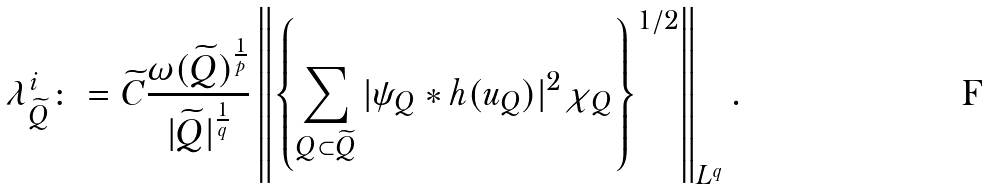Convert formula to latex. <formula><loc_0><loc_0><loc_500><loc_500>\lambda _ { \widetilde { Q } } ^ { i } \colon = \widetilde { C } \frac { \omega ( \widetilde { Q } ) ^ { \frac { 1 } { p } } } { | \widetilde { Q } | ^ { \frac { 1 } { q } } } \left \| \left \{ \sum _ { Q \subset \widetilde { Q } } | \psi _ { Q } \ast h ( u _ { Q } ) | ^ { 2 } \chi _ { Q } \right \} ^ { 1 / 2 } \right \| _ { L ^ { q } } .</formula> 